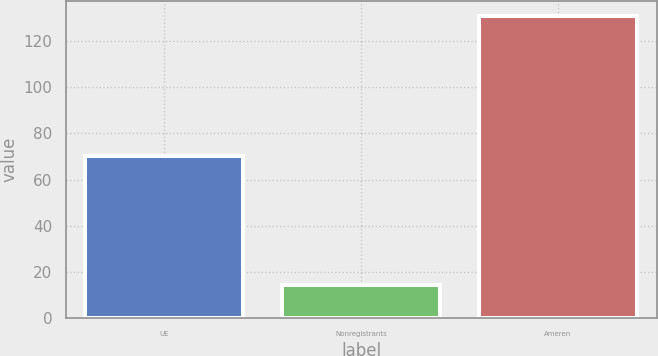Convert chart to OTSL. <chart><loc_0><loc_0><loc_500><loc_500><bar_chart><fcel>UE<fcel>Nonregistrants<fcel>Ameren<nl><fcel>70<fcel>14<fcel>131<nl></chart> 